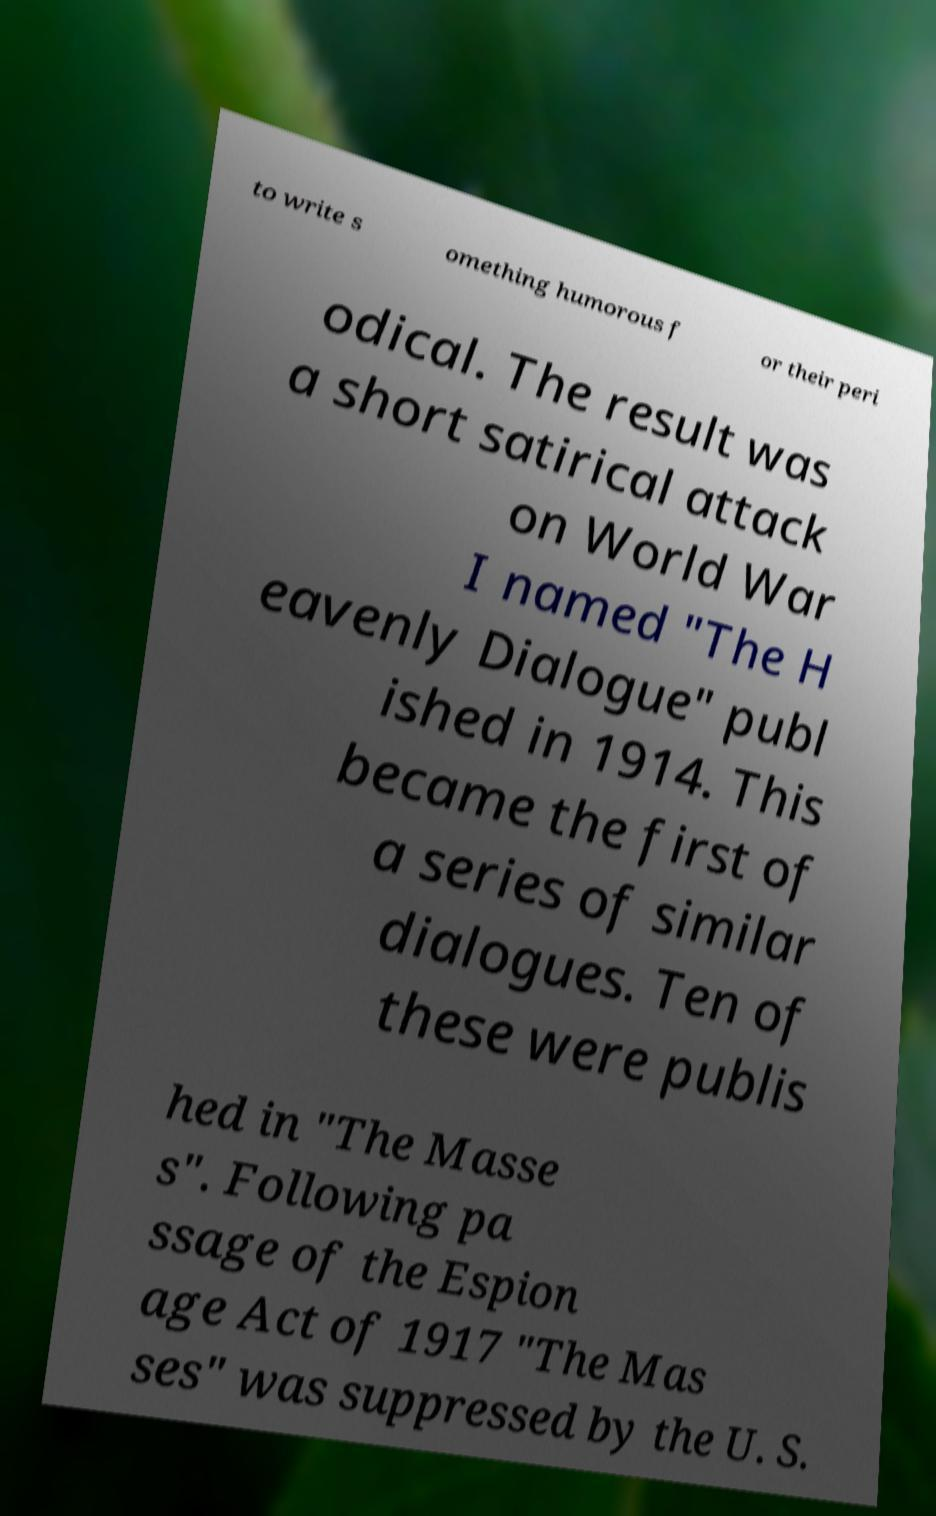Can you accurately transcribe the text from the provided image for me? to write s omething humorous f or their peri odical. The result was a short satirical attack on World War I named "The H eavenly Dialogue" publ ished in 1914. This became the first of a series of similar dialogues. Ten of these were publis hed in "The Masse s". Following pa ssage of the Espion age Act of 1917 "The Mas ses" was suppressed by the U. S. 